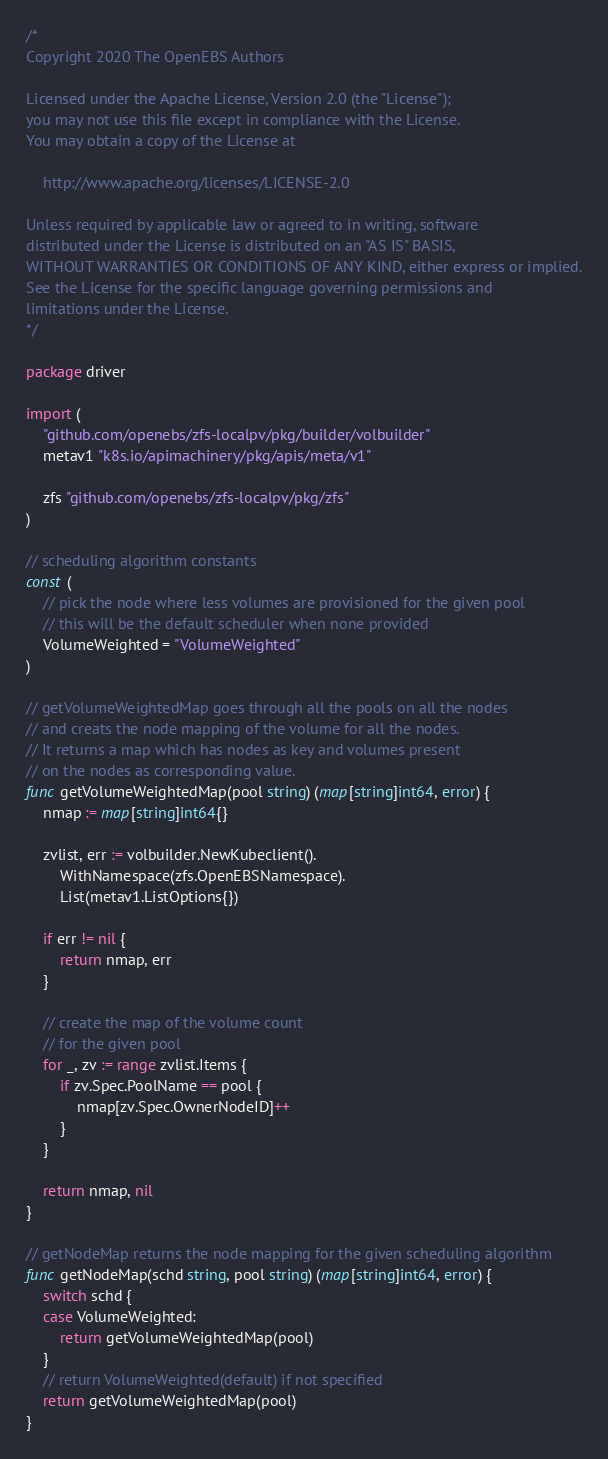<code> <loc_0><loc_0><loc_500><loc_500><_Go_>/*
Copyright 2020 The OpenEBS Authors

Licensed under the Apache License, Version 2.0 (the "License");
you may not use this file except in compliance with the License.
You may obtain a copy of the License at

    http://www.apache.org/licenses/LICENSE-2.0

Unless required by applicable law or agreed to in writing, software
distributed under the License is distributed on an "AS IS" BASIS,
WITHOUT WARRANTIES OR CONDITIONS OF ANY KIND, either express or implied.
See the License for the specific language governing permissions and
limitations under the License.
*/

package driver

import (
	"github.com/openebs/zfs-localpv/pkg/builder/volbuilder"
	metav1 "k8s.io/apimachinery/pkg/apis/meta/v1"

	zfs "github.com/openebs/zfs-localpv/pkg/zfs"
)

// scheduling algorithm constants
const (
	// pick the node where less volumes are provisioned for the given pool
	// this will be the default scheduler when none provided
	VolumeWeighted = "VolumeWeighted"
)

// getVolumeWeightedMap goes through all the pools on all the nodes
// and creats the node mapping of the volume for all the nodes.
// It returns a map which has nodes as key and volumes present
// on the nodes as corresponding value.
func getVolumeWeightedMap(pool string) (map[string]int64, error) {
	nmap := map[string]int64{}

	zvlist, err := volbuilder.NewKubeclient().
		WithNamespace(zfs.OpenEBSNamespace).
		List(metav1.ListOptions{})

	if err != nil {
		return nmap, err
	}

	// create the map of the volume count
	// for the given pool
	for _, zv := range zvlist.Items {
		if zv.Spec.PoolName == pool {
			nmap[zv.Spec.OwnerNodeID]++
		}
	}

	return nmap, nil
}

// getNodeMap returns the node mapping for the given scheduling algorithm
func getNodeMap(schd string, pool string) (map[string]int64, error) {
	switch schd {
	case VolumeWeighted:
		return getVolumeWeightedMap(pool)
	}
	// return VolumeWeighted(default) if not specified
	return getVolumeWeightedMap(pool)
}
</code> 